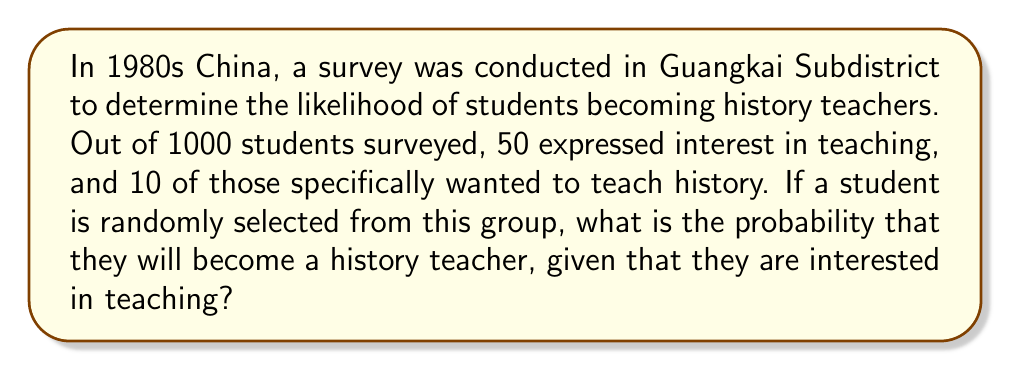Can you answer this question? Let's approach this step-by-step using conditional probability:

1) Define events:
   A: Student becomes a history teacher
   B: Student is interested in teaching

2) We need to find P(A|B), the probability of A given B.

3) The formula for conditional probability is:

   $$P(A|B) = \frac{P(A \cap B)}{P(B)}$$

4) From the data:
   - Total students: 1000
   - Students interested in teaching (B): 50
   - Students interested in teaching history (A ∩ B): 10

5) Calculate P(B):
   $$P(B) = \frac{50}{1000} = 0.05$$

6) Calculate P(A ∩ B):
   $$P(A \cap B) = \frac{10}{1000} = 0.01$$

7) Now, apply the conditional probability formula:

   $$P(A|B) = \frac{P(A \cap B)}{P(B)} = \frac{0.01}{0.05} = 0.2$$

Therefore, the probability that a student will become a history teacher, given that they are interested in teaching, is 0.2 or 20%.
Answer: 0.2 